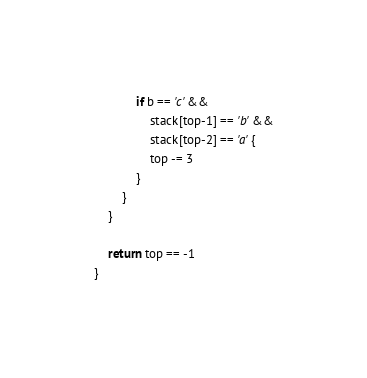<code> <loc_0><loc_0><loc_500><loc_500><_Go_>			if b == 'c' &&
				stack[top-1] == 'b' &&
				stack[top-2] == 'a' {
				top -= 3
			}
		}
	}

	return top == -1
}
</code> 